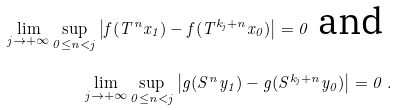<formula> <loc_0><loc_0><loc_500><loc_500>\lim _ { j \to + \infty } \sup _ { 0 \leq n < j } \left | f ( T ^ { n } x _ { 1 } ) - f ( T ^ { k _ { j } + n } x _ { 0 } ) \right | = 0 \text { and } \\ \lim _ { j \to + \infty } \sup _ { 0 \leq n < j } \left | g ( S ^ { n } y _ { 1 } ) - g ( S ^ { k _ { j } + n } y _ { 0 } ) \right | = 0 \ .</formula> 